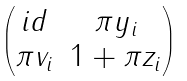Convert formula to latex. <formula><loc_0><loc_0><loc_500><loc_500>\begin{pmatrix} i d & \pi y _ { i } \\ \pi v _ { i } & 1 + \pi z _ { i } \end{pmatrix}</formula> 